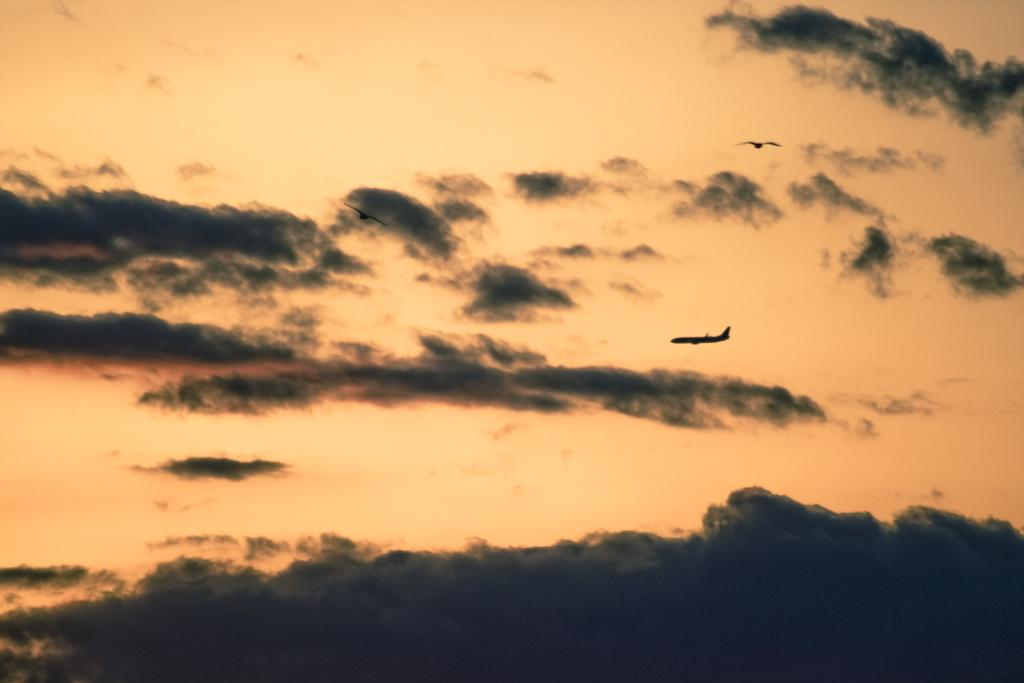What is the main subject of the image? The main subject of the image is an aircraft. Where is the aircraft located in the image? The aircraft is on the right side of the image. What is the aircraft's position in relation to the ground? The aircraft is in the sky. What type of mailbox can be seen near the aircraft in the image? There is no mailbox present in the image; it features an aircraft in the sky. What is the cause of the aircraft's movement in the image? The image does not show the aircraft in motion, so it is not possible to determine the cause of its movement. 